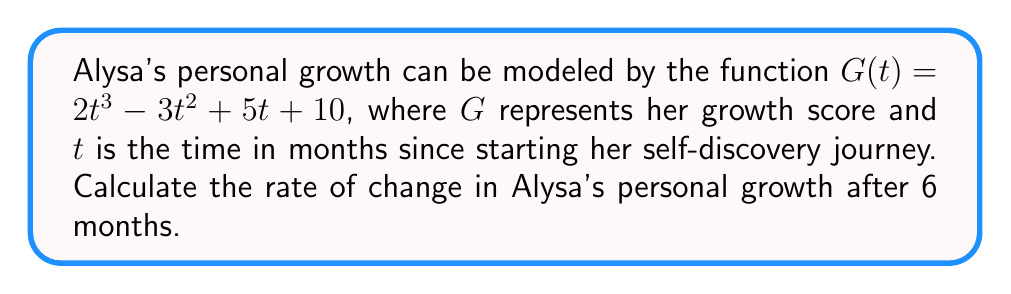Can you answer this question? To find the rate of change in Alysa's personal growth after 6 months, we need to:

1. Find the derivative of the growth function $G(t)$
2. Evaluate the derivative at $t = 6$

Step 1: Find the derivative of $G(t)$

The derivative of $G(t)$ represents the instantaneous rate of change of growth with respect to time. We'll use the power rule and constant rule of differentiation:

$$\frac{d}{dt}G(t) = \frac{d}{dt}(2t^3 - 3t^2 + 5t + 10)$$
$$G'(t) = 6t^2 - 6t + 5$$

Step 2: Evaluate the derivative at $t = 6$

Now that we have the derivative function, we can substitute $t = 6$ to find the rate of change at 6 months:

$$G'(6) = 6(6)^2 - 6(6) + 5$$
$$G'(6) = 6(36) - 36 + 5$$
$$G'(6) = 216 - 36 + 5$$
$$G'(6) = 185$$

Therefore, after 6 months, Alysa's personal growth is changing at a rate of 185 growth score units per month.
Answer: $185$ growth score units per month 